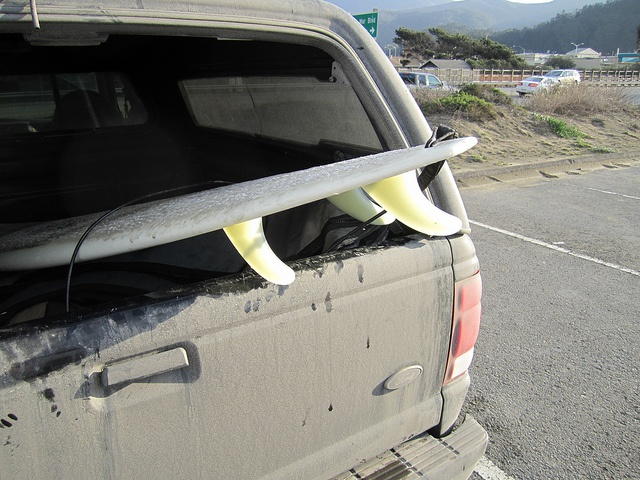Describe the objects in this image and their specific colors. I can see truck in black, darkgray, gray, and lightgray tones, car in black, darkgray, gray, and lightgray tones, surfboard in black, lightgray, darkgray, and gray tones, car in black, darkgray, gray, and lightgray tones, and car in black, darkgray, lightgray, and lightblue tones in this image. 